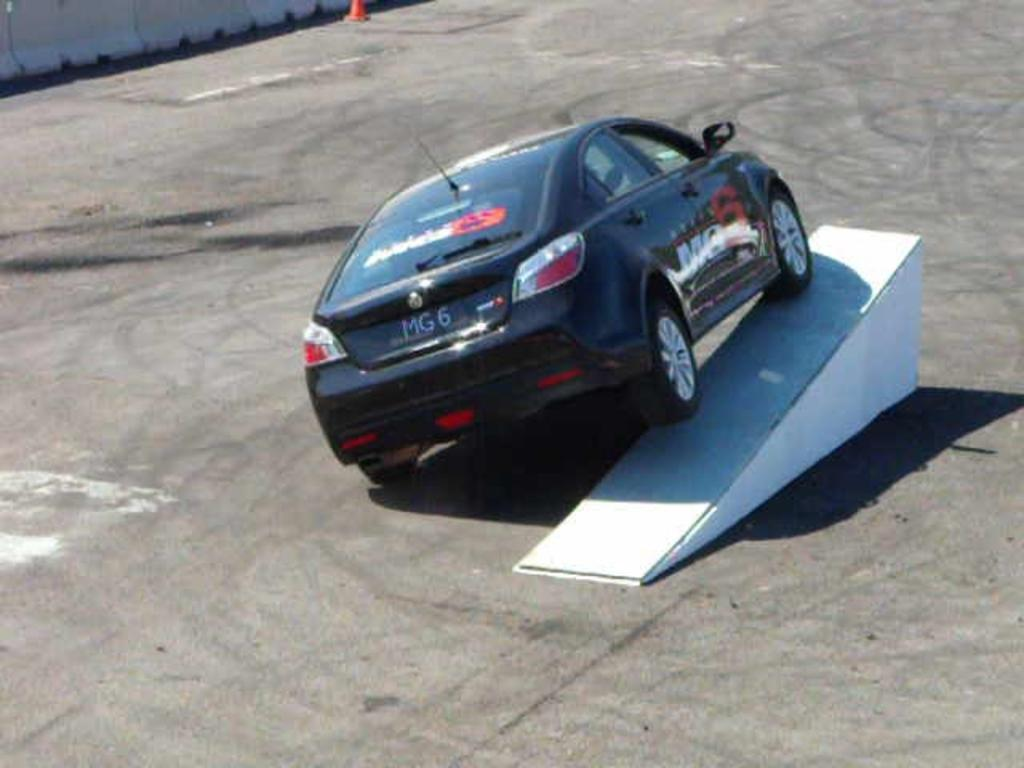What is the main subject of the image? The main subject of the image is a car. What is the car resting on? The car is on a white object. What can be seen in the background of the image? There is a traffic cone and a wall in the background of the image. What type of iron can be seen hanging from the wall in the image? There is no iron present in the image; it features a car on a white object with a traffic cone and a wall in the background. 